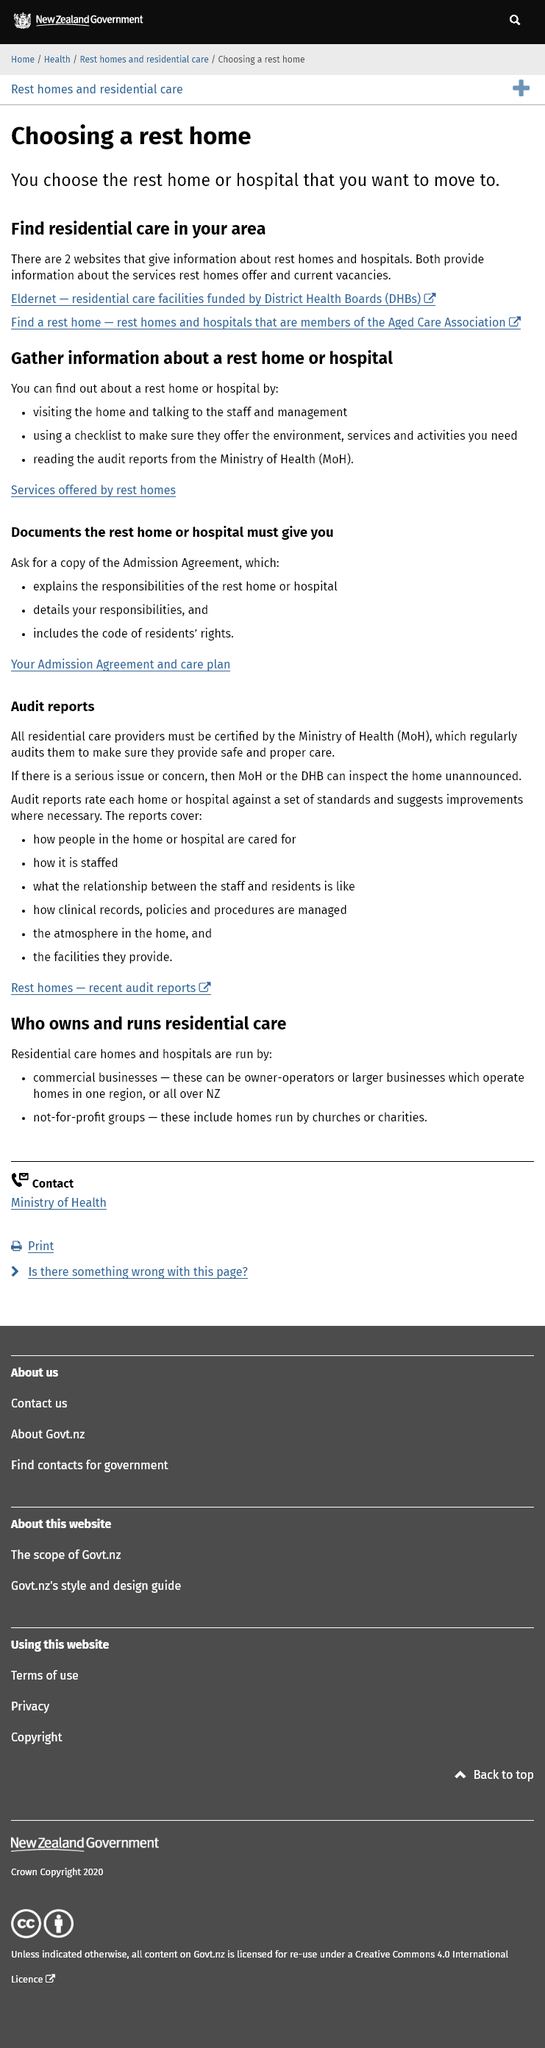Draw attention to some important aspects in this diagram. There are two websites that can assist in finding vacancies in hospitals, and they are capable of providing a significant amount of help. The atmosphere in the home would be included in an MoH audit report. To obtain audit reports for rest homes, they can be obtained from the Ministry of Health. Eldernet provides information about current rest home vacancies. Residents' rights can be found in the Admission Agreement. 